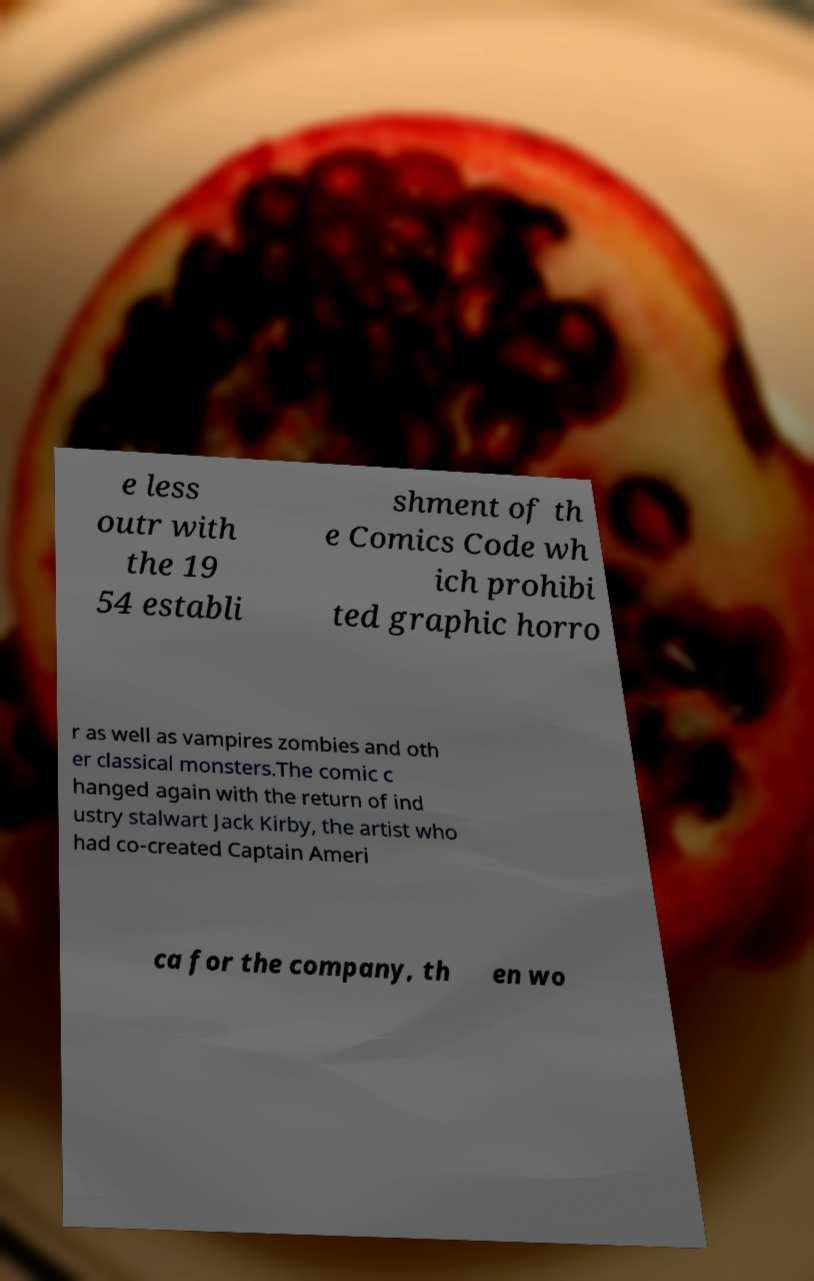Can you accurately transcribe the text from the provided image for me? e less outr with the 19 54 establi shment of th e Comics Code wh ich prohibi ted graphic horro r as well as vampires zombies and oth er classical monsters.The comic c hanged again with the return of ind ustry stalwart Jack Kirby, the artist who had co-created Captain Ameri ca for the company, th en wo 